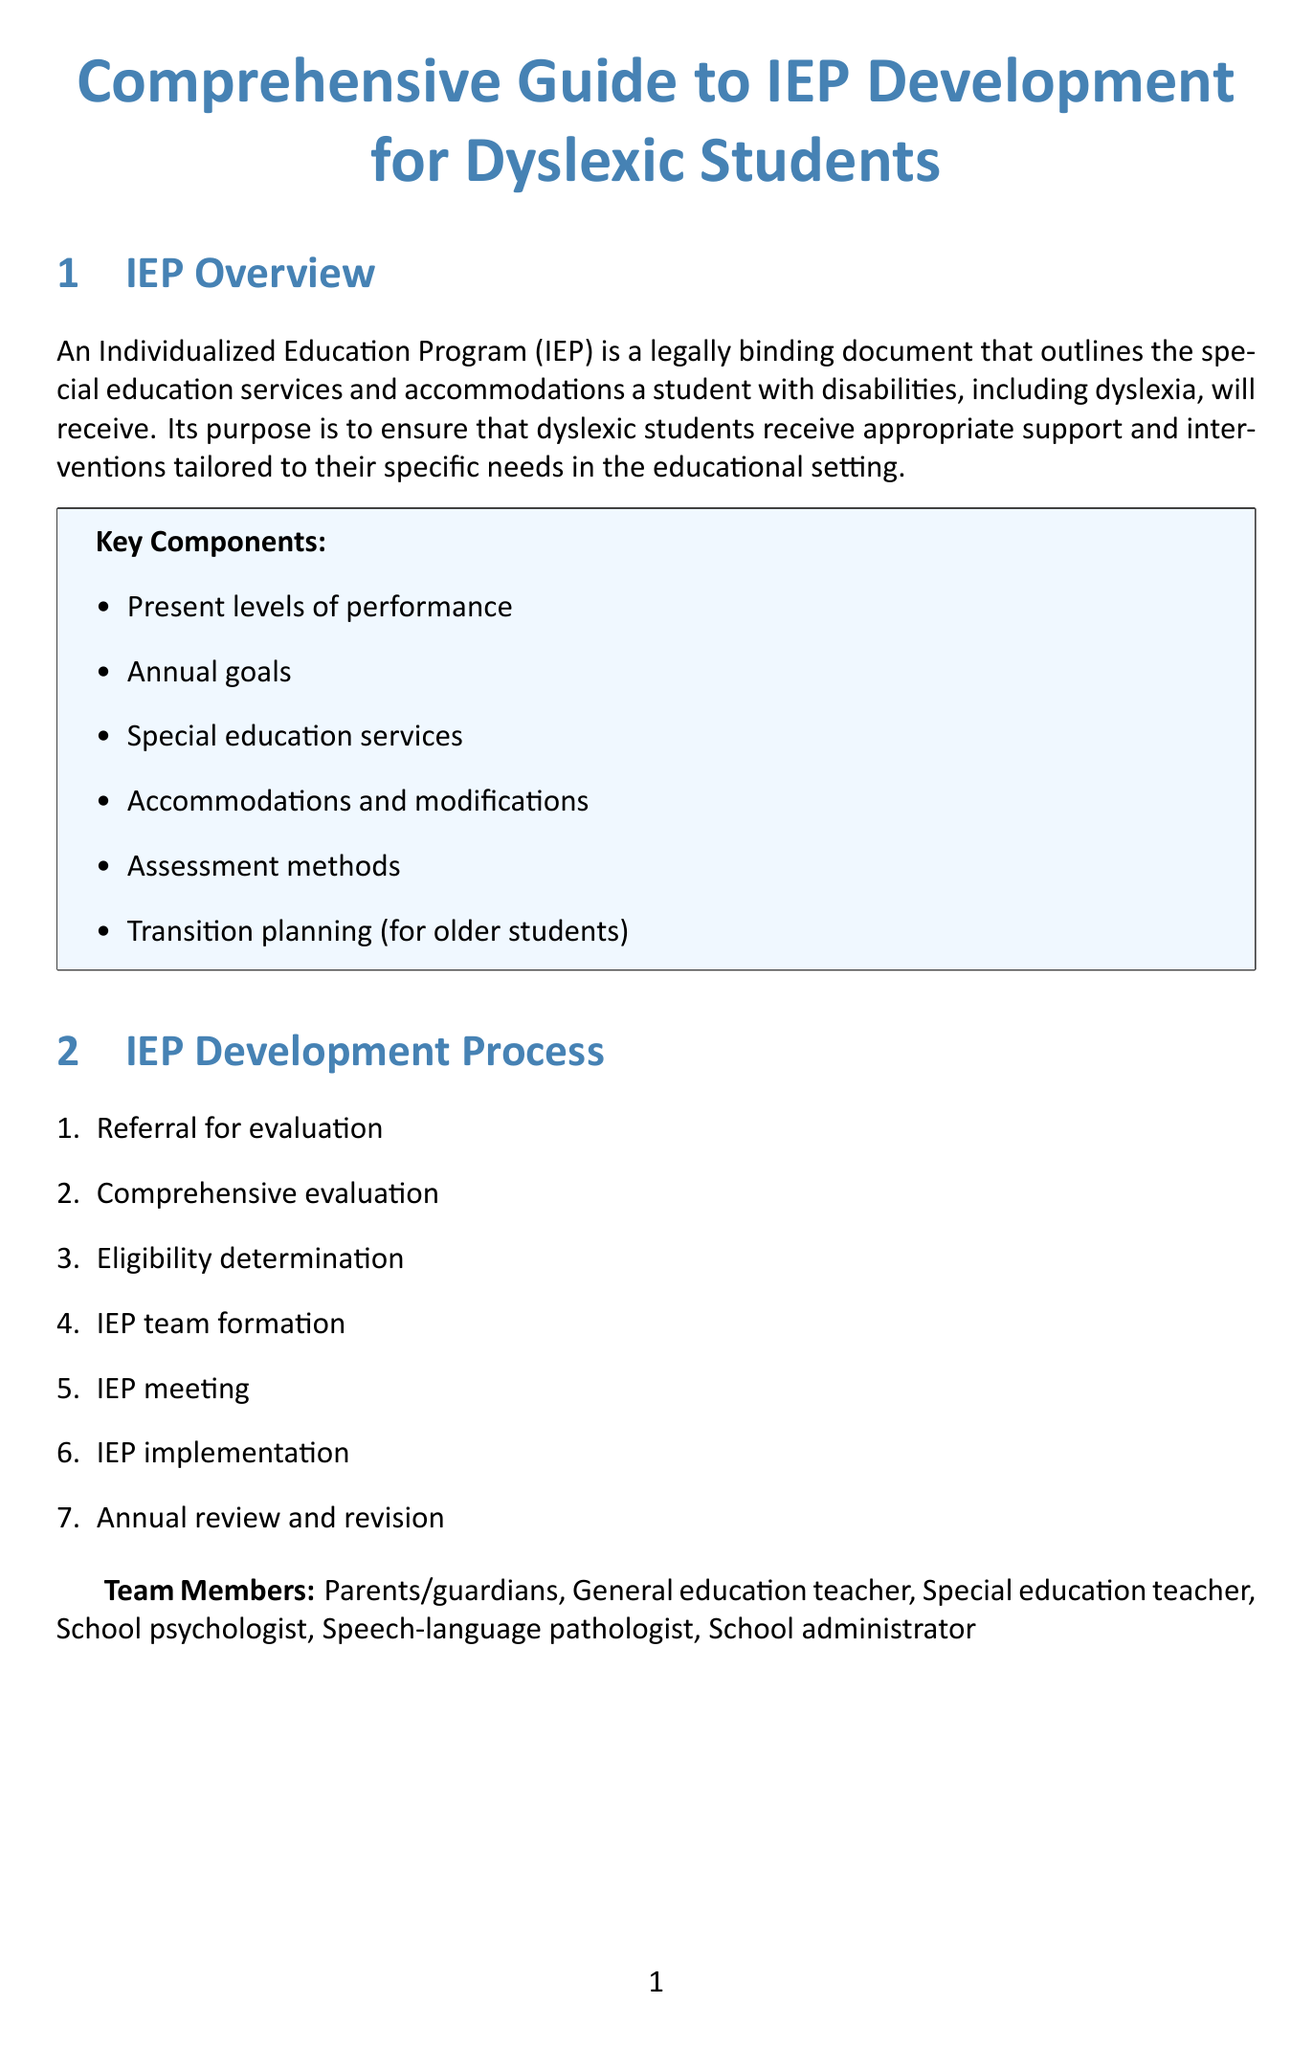What is the definition of an IEP? The definition provided in the document states that an Individualized Education Program (IEP) is a legally binding document that outlines the special education services and accommodations a student with disabilities, including dyslexia, will receive.
Answer: legally binding document What is the purpose of the IEP? The purpose of the IEP is stated in the document as ensuring that dyslexic students receive appropriate support and interventions tailored to their specific needs in the educational setting.
Answer: appropriate support How many steps are in the IEP development process? The document lists seven steps in the IEP development process, indicating a structured approach to creating the IEP.
Answer: 7 Name one instructional strategy for dyslexic students. The document highlights several instructional strategies, such as a multisensory approach, which are effective for dyslexic students.
Answer: multisensory approach What is one of the parental rights listed in the document? The document mentions several parental rights, including the right to participate in IEP meetings, emphasizing the importance of parent involvement.
Answer: right to participate What is the frequency of progress monitoring as specified? The document specifies that progress monitoring typically occurs every 6-8 weeks, allowing for regular assessment of the student's progress.
Answer: every 6-8 weeks Which law is relevant to the IEP? The document lists several relevant laws, one of which is the Individuals with Disabilities Education Act (IDEA), which governs IEP development and implementation.
Answer: Individuals with Disabilities Education Act What are key areas of transition planning? The document outlines key areas of transition planning for dyslexic students, including self-advocacy skills and college preparation, which are important for their future success.
Answer: self-advocacy skills What is one type of resource mentioned for parents? The document lists various resources for parents, such as organizations that provide support and information about dyslexia.
Answer: International Dyslexia Association 